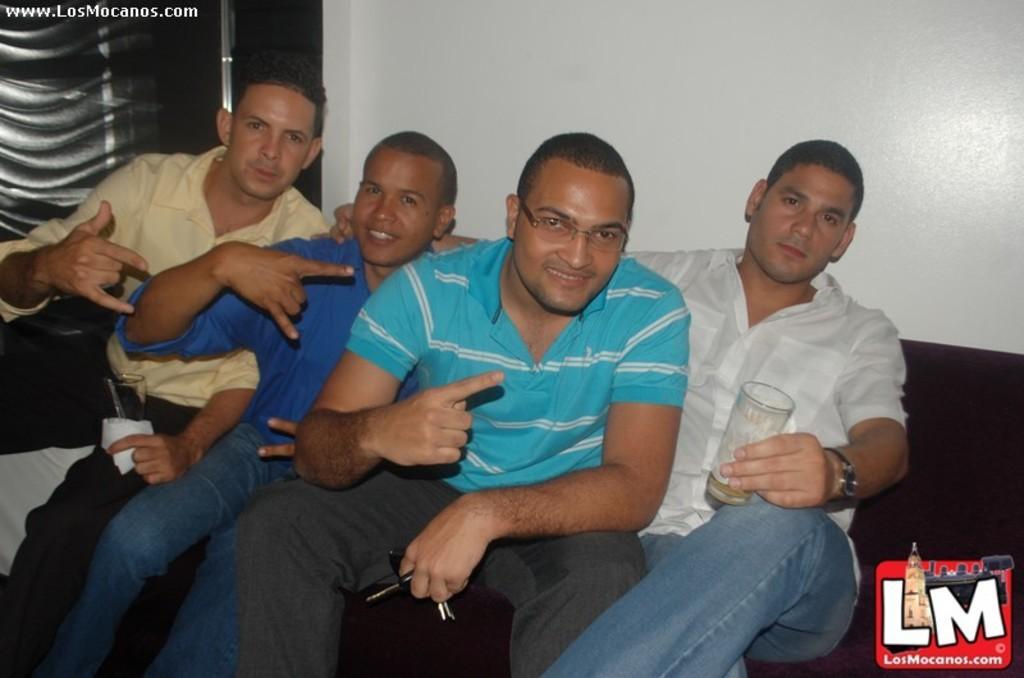Can you describe this image briefly? In this picture we see few people seated on the sofa and i see couple of them holding glasses in their hands and a man holding sunglasses in his hand and wall on the back and text at the top left corner and logo at the bottom right corner of the picture. 